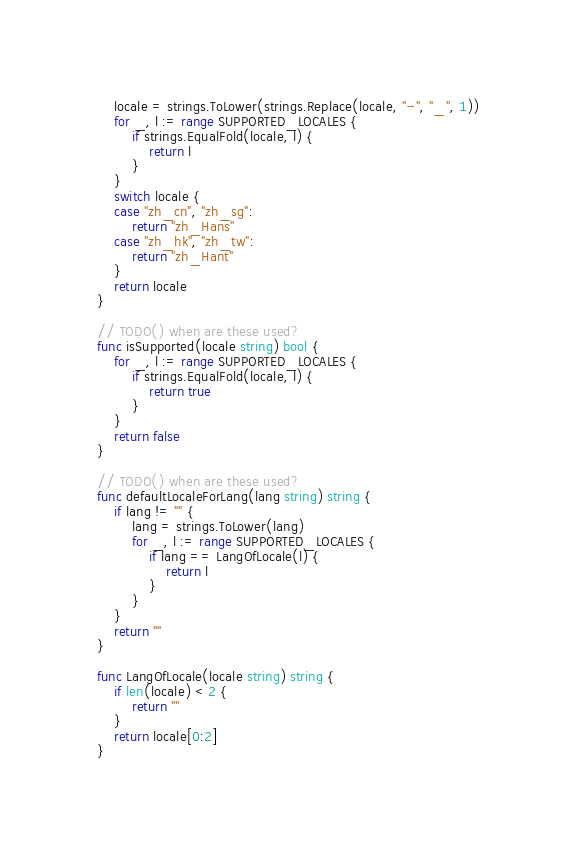Convert code to text. <code><loc_0><loc_0><loc_500><loc_500><_Go_>	locale = strings.ToLower(strings.Replace(locale, "-", "_", 1))
	for _, l := range SUPPORTED_LOCALES {
		if strings.EqualFold(locale, l) {
			return l
		}
	}
	switch locale {
	case "zh_cn", "zh_sg":
		return "zh_Hans"
	case "zh_hk", "zh_tw":
		return "zh_Hant"
	}
	return locale
}

// TODO() when are these used?
func isSupported(locale string) bool {
	for _, l := range SUPPORTED_LOCALES {
		if strings.EqualFold(locale, l) {
			return true
		}
	}
	return false
}

// TODO() when are these used?
func defaultLocaleForLang(lang string) string {
	if lang != "" {
		lang = strings.ToLower(lang)
		for _, l := range SUPPORTED_LOCALES {
			if lang == LangOfLocale(l) {
				return l
			}
		}
	}
	return ""
}

func LangOfLocale(locale string) string {
	if len(locale) < 2 {
		return ""
	}
	return locale[0:2]
}
</code> 